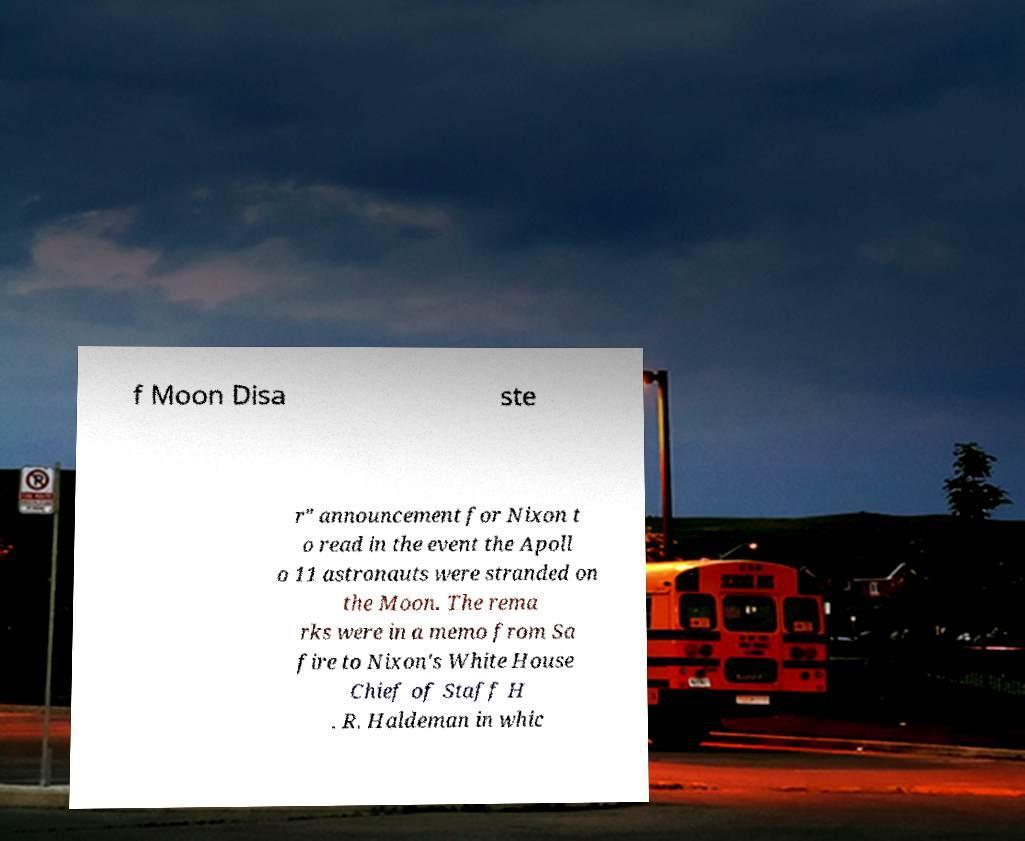Could you extract and type out the text from this image? f Moon Disa ste r" announcement for Nixon t o read in the event the Apoll o 11 astronauts were stranded on the Moon. The rema rks were in a memo from Sa fire to Nixon's White House Chief of Staff H . R. Haldeman in whic 